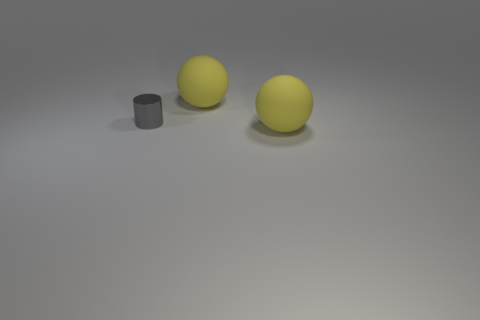Add 3 small shiny cylinders. How many objects exist? 6 Subtract all cylinders. How many objects are left? 2 Subtract all cyan spheres. Subtract all purple cylinders. How many spheres are left? 2 Subtract all cyan spheres. How many cyan cylinders are left? 0 Subtract all gray cylinders. Subtract all big yellow spheres. How many objects are left? 0 Add 1 gray things. How many gray things are left? 2 Add 1 tiny gray shiny things. How many tiny gray shiny things exist? 2 Subtract 0 purple balls. How many objects are left? 3 